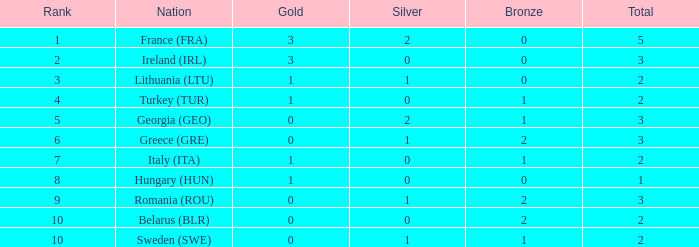With 0 silver medals and over 1 gold medal, what is the overall total for rank 8? 0.0. 